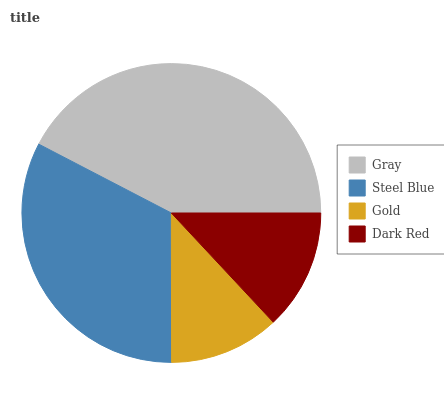Is Gold the minimum?
Answer yes or no. Yes. Is Gray the maximum?
Answer yes or no. Yes. Is Steel Blue the minimum?
Answer yes or no. No. Is Steel Blue the maximum?
Answer yes or no. No. Is Gray greater than Steel Blue?
Answer yes or no. Yes. Is Steel Blue less than Gray?
Answer yes or no. Yes. Is Steel Blue greater than Gray?
Answer yes or no. No. Is Gray less than Steel Blue?
Answer yes or no. No. Is Steel Blue the high median?
Answer yes or no. Yes. Is Dark Red the low median?
Answer yes or no. Yes. Is Gray the high median?
Answer yes or no. No. Is Steel Blue the low median?
Answer yes or no. No. 